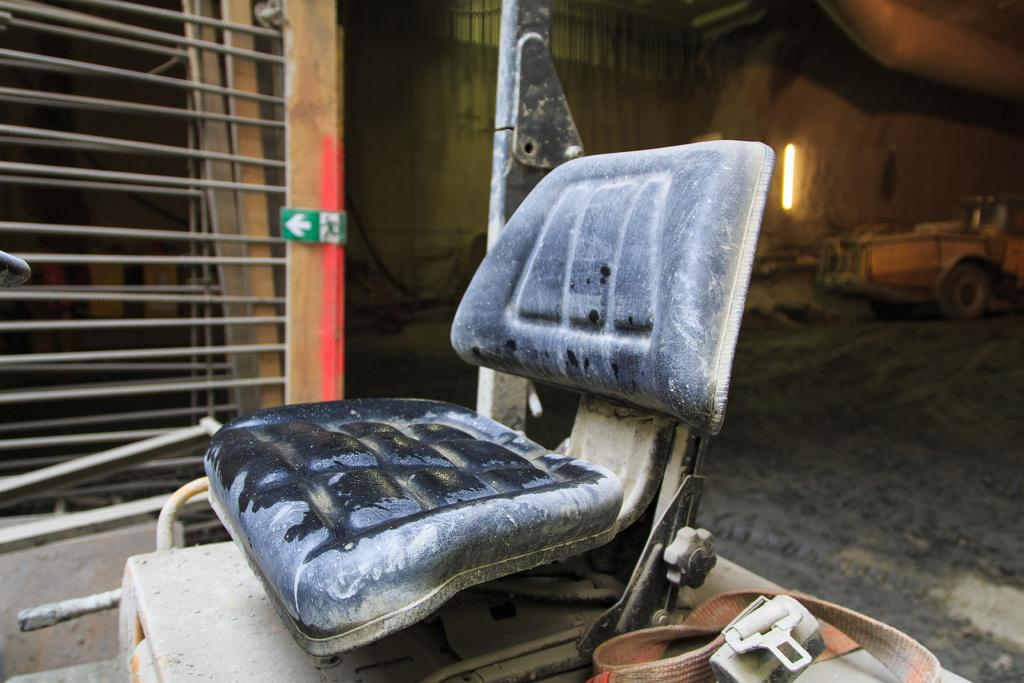What is present on the sheet in the image? The facts provided do not specify any objects or details on the sheet. What type of accessory is visible in the image? There is a belt in the image. What can be seen in the background of the image? There is a vehicle in the background of the image. What surface is visible in the image? There is a floor visible in the image. What is located on the left side of the image? There is a grill on the left side of the image. How many horses are present in the image? There are no horses present in the image. Can you describe the sleeping habits of the cats in the image? There are no cats present in the image. 